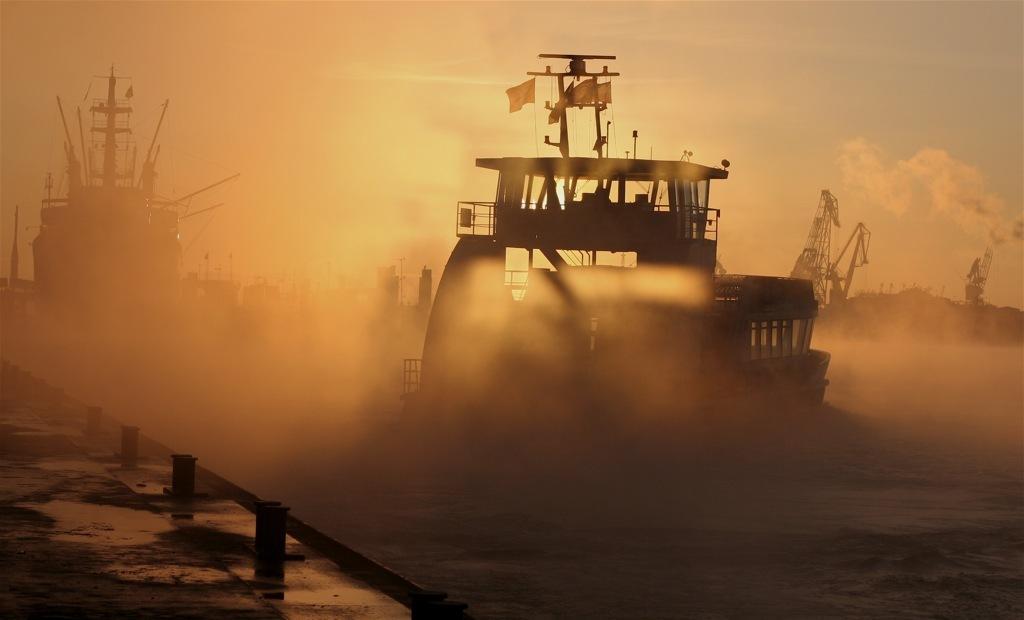Please provide a concise description of this image. In this image we can see a few ships on the water, there are some flags and mountains, in the background we can see the sky with clouds. 